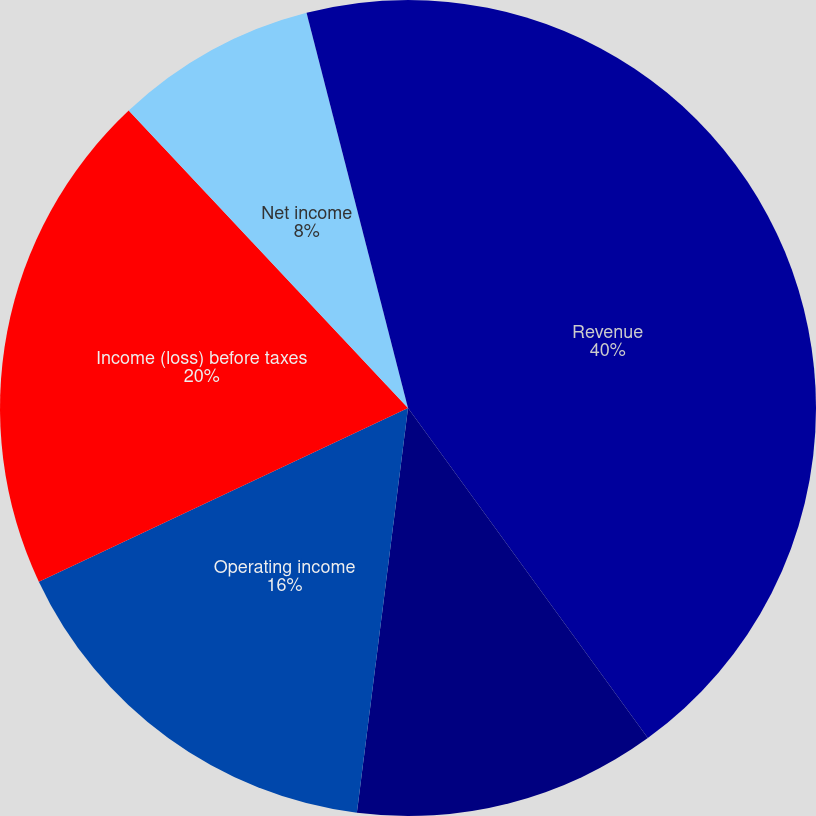<chart> <loc_0><loc_0><loc_500><loc_500><pie_chart><fcel>Revenue<fcel>Operating income (loss) (a)<fcel>Operating income<fcel>Income (loss) before taxes<fcel>Net income<fcel>Basic<fcel>Diluted<nl><fcel>40.0%<fcel>12.0%<fcel>16.0%<fcel>20.0%<fcel>8.0%<fcel>0.0%<fcel>4.0%<nl></chart> 